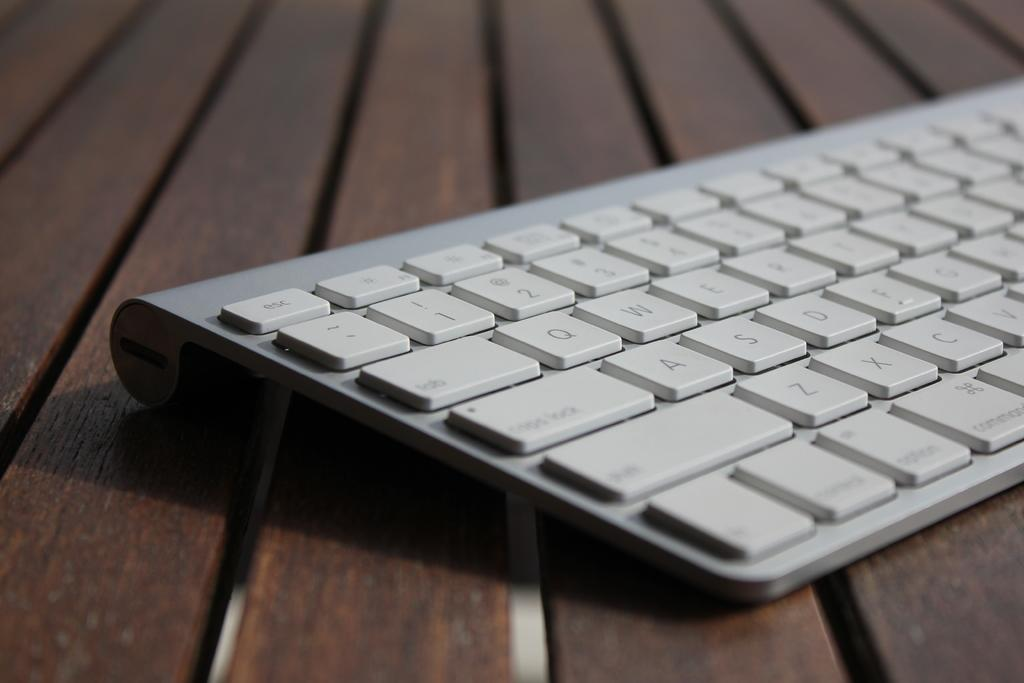<image>
Give a short and clear explanation of the subsequent image. A white keyboard which has an esc key at the top left. 